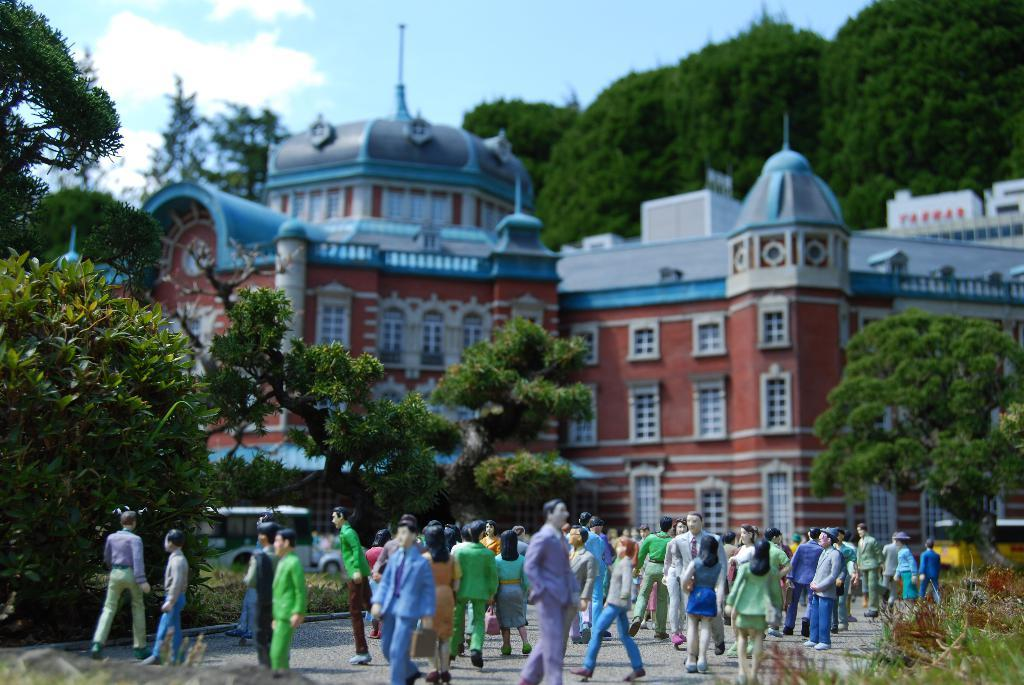What type of structure is visible in the image? There is a building in the image. What feature can be seen on the building? The building has windows. What type of objects are present in the image? There are toys of people wearing clothes and trees in the image. What type of ground surface is visible in the image? There is a road and grass in the image. What is the condition of the sky in the image? The sky is cloudy in the image. What type of creature can be seen climbing the building in the image? There is no creature climbing the building in the image; it only shows the building, trees, toys, and the sky. How many times does the person in the image fall while walking on the grass? There is no person walking on the grass in the image, so it is impossible to determine how many times they might fall. 